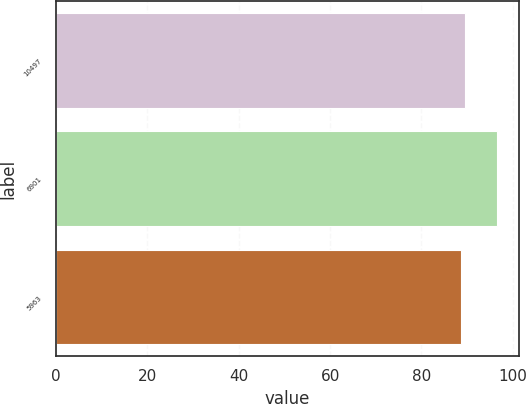Convert chart. <chart><loc_0><loc_0><loc_500><loc_500><bar_chart><fcel>10497<fcel>6901<fcel>5963<nl><fcel>89.48<fcel>96.5<fcel>88.7<nl></chart> 